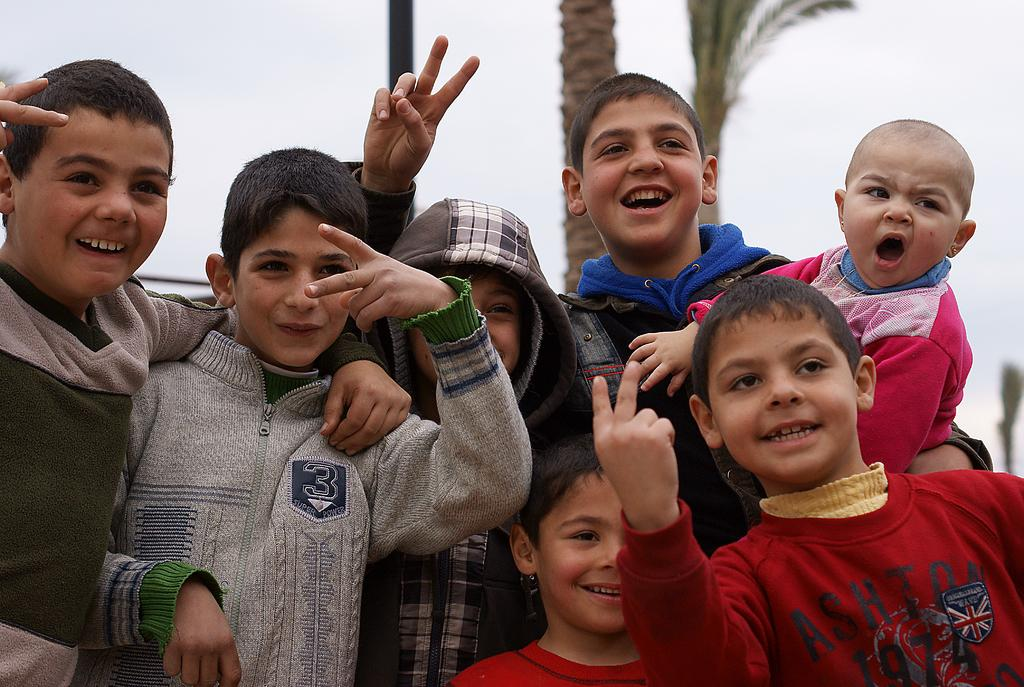Who is present in the image? There are children in the image. What are the children doing in the image? The children are posing for a photograph. What can be seen in the background of the image? There is a tree and a pole in the background of the image. What type of attention-seeking beast can be seen in the image? There is no beast present in the image; it features children posing for a photograph with a tree and a pole in the background. 